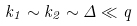<formula> <loc_0><loc_0><loc_500><loc_500>k _ { 1 } \sim k _ { 2 } \sim \Delta \ll q</formula> 